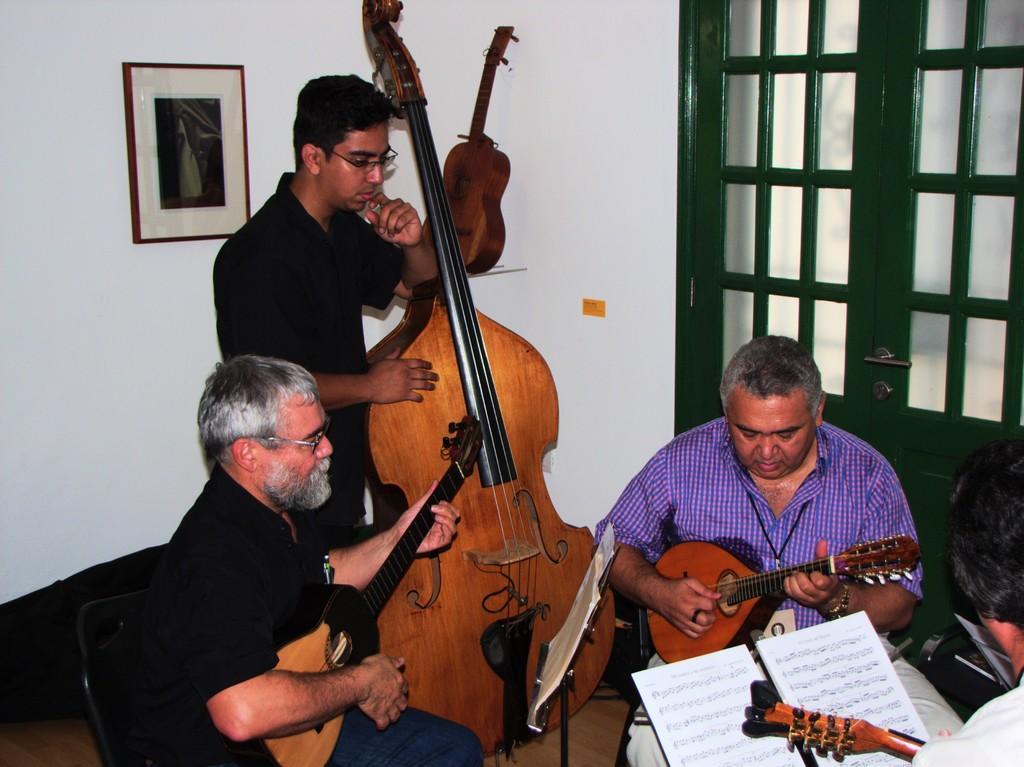Can you describe this image briefly? It may be a music class there are total four people three are sitting and the person a person wearing black shirt is standing and holding a guitar, all of them are playing the instruments in the background there is a white color wall and a photo frame to the right side there is a wall. 